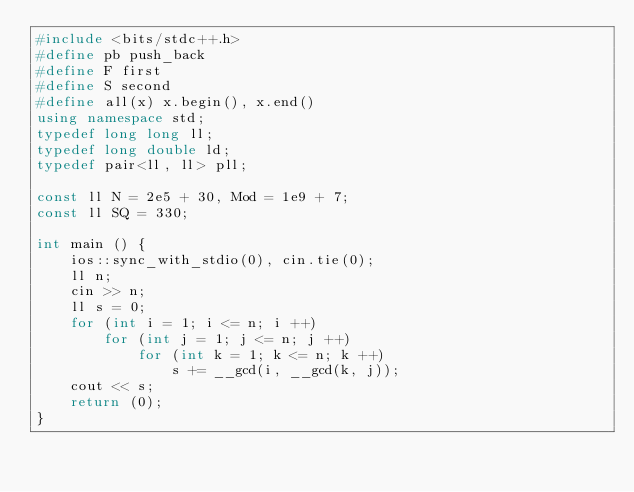<code> <loc_0><loc_0><loc_500><loc_500><_C++_>#include <bits/stdc++.h>
#define pb push_back
#define F first
#define S second
#define all(x) x.begin(), x.end()
using namespace std;
typedef long long ll; 
typedef long double ld;
typedef pair<ll, ll> pll;

const ll N = 2e5 + 30, Mod = 1e9 + 7;
const ll SQ = 330;

int main () {
    ios::sync_with_stdio(0), cin.tie(0);
    ll n;
    cin >> n;
    ll s = 0;
    for (int i = 1; i <= n; i ++)
    	for (int j = 1; j <= n; j ++)
    		for (int k = 1; k <= n; k ++)
    			s += __gcd(i, __gcd(k, j));
    cout << s;
    return (0);
}</code> 